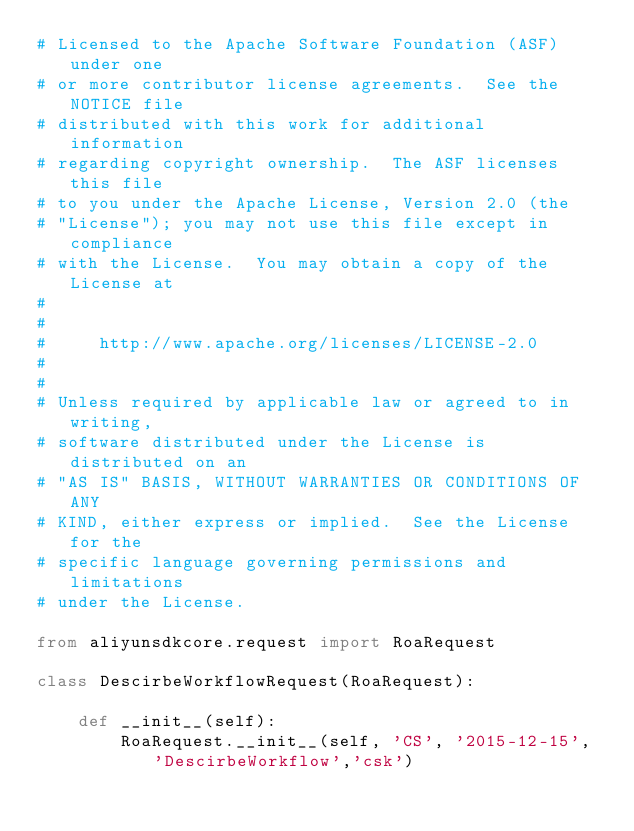Convert code to text. <code><loc_0><loc_0><loc_500><loc_500><_Python_># Licensed to the Apache Software Foundation (ASF) under one
# or more contributor license agreements.  See the NOTICE file
# distributed with this work for additional information
# regarding copyright ownership.  The ASF licenses this file
# to you under the Apache License, Version 2.0 (the
# "License"); you may not use this file except in compliance
# with the License.  You may obtain a copy of the License at
#
#
#     http://www.apache.org/licenses/LICENSE-2.0
#
#
# Unless required by applicable law or agreed to in writing,
# software distributed under the License is distributed on an
# "AS IS" BASIS, WITHOUT WARRANTIES OR CONDITIONS OF ANY
# KIND, either express or implied.  See the License for the
# specific language governing permissions and limitations
# under the License.

from aliyunsdkcore.request import RoaRequest

class DescirbeWorkflowRequest(RoaRequest):

	def __init__(self):
		RoaRequest.__init__(self, 'CS', '2015-12-15', 'DescirbeWorkflow','csk')</code> 